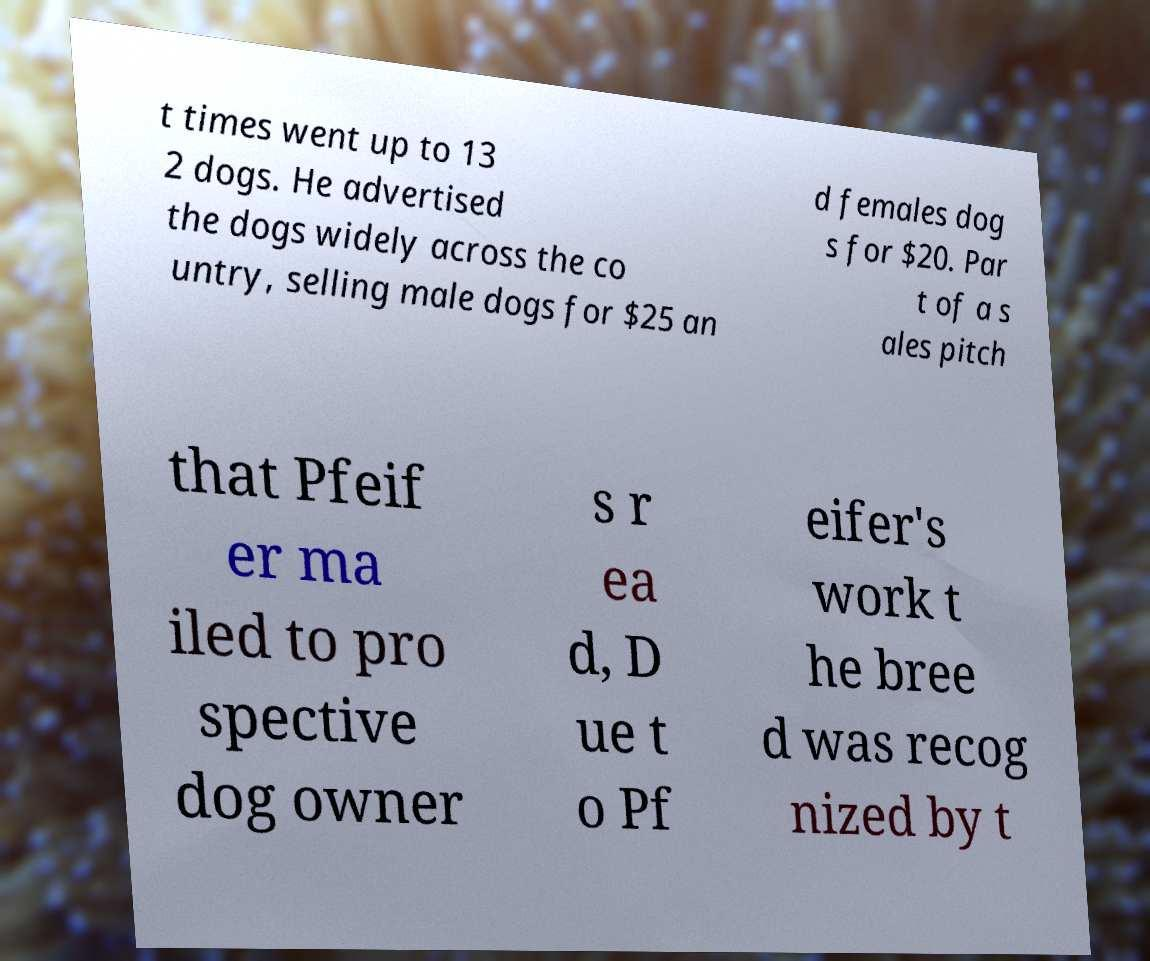Can you read and provide the text displayed in the image?This photo seems to have some interesting text. Can you extract and type it out for me? t times went up to 13 2 dogs. He advertised the dogs widely across the co untry, selling male dogs for $25 an d females dog s for $20. Par t of a s ales pitch that Pfeif er ma iled to pro spective dog owner s r ea d, D ue t o Pf eifer's work t he bree d was recog nized by t 